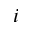<formula> <loc_0><loc_0><loc_500><loc_500>i</formula> 